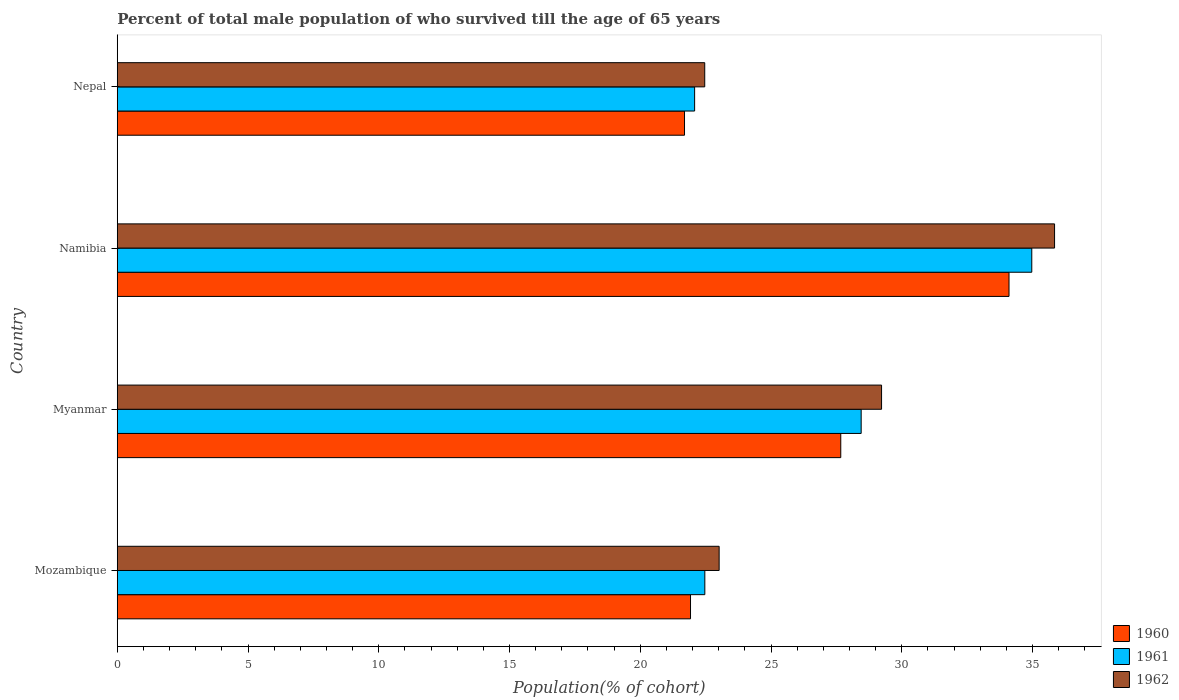How many groups of bars are there?
Give a very brief answer. 4. Are the number of bars per tick equal to the number of legend labels?
Offer a very short reply. Yes. Are the number of bars on each tick of the Y-axis equal?
Offer a very short reply. Yes. How many bars are there on the 4th tick from the top?
Keep it short and to the point. 3. What is the label of the 3rd group of bars from the top?
Ensure brevity in your answer.  Myanmar. What is the percentage of total male population who survived till the age of 65 years in 1962 in Myanmar?
Your answer should be very brief. 29.23. Across all countries, what is the maximum percentage of total male population who survived till the age of 65 years in 1962?
Your response must be concise. 35.84. Across all countries, what is the minimum percentage of total male population who survived till the age of 65 years in 1961?
Your answer should be compact. 22.08. In which country was the percentage of total male population who survived till the age of 65 years in 1960 maximum?
Make the answer very short. Namibia. In which country was the percentage of total male population who survived till the age of 65 years in 1962 minimum?
Ensure brevity in your answer.  Nepal. What is the total percentage of total male population who survived till the age of 65 years in 1961 in the graph?
Keep it short and to the point. 107.96. What is the difference between the percentage of total male population who survived till the age of 65 years in 1962 in Namibia and that in Nepal?
Your answer should be compact. 13.38. What is the difference between the percentage of total male population who survived till the age of 65 years in 1961 in Myanmar and the percentage of total male population who survived till the age of 65 years in 1962 in Nepal?
Keep it short and to the point. 5.98. What is the average percentage of total male population who survived till the age of 65 years in 1961 per country?
Offer a very short reply. 26.99. What is the difference between the percentage of total male population who survived till the age of 65 years in 1960 and percentage of total male population who survived till the age of 65 years in 1961 in Nepal?
Offer a very short reply. -0.39. What is the ratio of the percentage of total male population who survived till the age of 65 years in 1960 in Myanmar to that in Nepal?
Offer a terse response. 1.28. Is the percentage of total male population who survived till the age of 65 years in 1960 in Mozambique less than that in Namibia?
Make the answer very short. Yes. What is the difference between the highest and the second highest percentage of total male population who survived till the age of 65 years in 1960?
Your answer should be very brief. 6.43. What is the difference between the highest and the lowest percentage of total male population who survived till the age of 65 years in 1960?
Your answer should be very brief. 12.41. In how many countries, is the percentage of total male population who survived till the age of 65 years in 1961 greater than the average percentage of total male population who survived till the age of 65 years in 1961 taken over all countries?
Make the answer very short. 2. Is the sum of the percentage of total male population who survived till the age of 65 years in 1962 in Myanmar and Namibia greater than the maximum percentage of total male population who survived till the age of 65 years in 1960 across all countries?
Your response must be concise. Yes. Is it the case that in every country, the sum of the percentage of total male population who survived till the age of 65 years in 1962 and percentage of total male population who survived till the age of 65 years in 1961 is greater than the percentage of total male population who survived till the age of 65 years in 1960?
Your answer should be compact. Yes. How many bars are there?
Keep it short and to the point. 12. What is the difference between two consecutive major ticks on the X-axis?
Your answer should be compact. 5. Are the values on the major ticks of X-axis written in scientific E-notation?
Ensure brevity in your answer.  No. Does the graph contain grids?
Keep it short and to the point. No. How are the legend labels stacked?
Your response must be concise. Vertical. What is the title of the graph?
Make the answer very short. Percent of total male population of who survived till the age of 65 years. Does "2011" appear as one of the legend labels in the graph?
Your answer should be compact. No. What is the label or title of the X-axis?
Keep it short and to the point. Population(% of cohort). What is the Population(% of cohort) of 1960 in Mozambique?
Offer a terse response. 21.92. What is the Population(% of cohort) in 1961 in Mozambique?
Your answer should be compact. 22.47. What is the Population(% of cohort) of 1962 in Mozambique?
Ensure brevity in your answer.  23.02. What is the Population(% of cohort) in 1960 in Myanmar?
Provide a short and direct response. 27.67. What is the Population(% of cohort) of 1961 in Myanmar?
Make the answer very short. 28.45. What is the Population(% of cohort) of 1962 in Myanmar?
Your response must be concise. 29.23. What is the Population(% of cohort) of 1960 in Namibia?
Your answer should be compact. 34.1. What is the Population(% of cohort) of 1961 in Namibia?
Your response must be concise. 34.97. What is the Population(% of cohort) of 1962 in Namibia?
Your answer should be very brief. 35.84. What is the Population(% of cohort) in 1960 in Nepal?
Offer a very short reply. 21.69. What is the Population(% of cohort) of 1961 in Nepal?
Offer a terse response. 22.08. What is the Population(% of cohort) in 1962 in Nepal?
Your response must be concise. 22.46. Across all countries, what is the maximum Population(% of cohort) in 1960?
Keep it short and to the point. 34.1. Across all countries, what is the maximum Population(% of cohort) in 1961?
Make the answer very short. 34.97. Across all countries, what is the maximum Population(% of cohort) in 1962?
Your response must be concise. 35.84. Across all countries, what is the minimum Population(% of cohort) in 1960?
Give a very brief answer. 21.69. Across all countries, what is the minimum Population(% of cohort) in 1961?
Your response must be concise. 22.08. Across all countries, what is the minimum Population(% of cohort) of 1962?
Ensure brevity in your answer.  22.46. What is the total Population(% of cohort) of 1960 in the graph?
Your answer should be compact. 105.38. What is the total Population(% of cohort) in 1961 in the graph?
Make the answer very short. 107.96. What is the total Population(% of cohort) in 1962 in the graph?
Your response must be concise. 110.55. What is the difference between the Population(% of cohort) of 1960 in Mozambique and that in Myanmar?
Give a very brief answer. -5.75. What is the difference between the Population(% of cohort) of 1961 in Mozambique and that in Myanmar?
Make the answer very short. -5.98. What is the difference between the Population(% of cohort) of 1962 in Mozambique and that in Myanmar?
Offer a terse response. -6.21. What is the difference between the Population(% of cohort) in 1960 in Mozambique and that in Namibia?
Your answer should be very brief. -12.18. What is the difference between the Population(% of cohort) in 1961 in Mozambique and that in Namibia?
Your answer should be very brief. -12.5. What is the difference between the Population(% of cohort) of 1962 in Mozambique and that in Namibia?
Offer a very short reply. -12.83. What is the difference between the Population(% of cohort) of 1960 in Mozambique and that in Nepal?
Keep it short and to the point. 0.23. What is the difference between the Population(% of cohort) in 1961 in Mozambique and that in Nepal?
Ensure brevity in your answer.  0.39. What is the difference between the Population(% of cohort) of 1962 in Mozambique and that in Nepal?
Keep it short and to the point. 0.55. What is the difference between the Population(% of cohort) in 1960 in Myanmar and that in Namibia?
Your answer should be compact. -6.43. What is the difference between the Population(% of cohort) in 1961 in Myanmar and that in Namibia?
Make the answer very short. -6.52. What is the difference between the Population(% of cohort) of 1962 in Myanmar and that in Namibia?
Provide a short and direct response. -6.62. What is the difference between the Population(% of cohort) in 1960 in Myanmar and that in Nepal?
Provide a succinct answer. 5.98. What is the difference between the Population(% of cohort) of 1961 in Myanmar and that in Nepal?
Offer a very short reply. 6.37. What is the difference between the Population(% of cohort) of 1962 in Myanmar and that in Nepal?
Your answer should be very brief. 6.76. What is the difference between the Population(% of cohort) in 1960 in Namibia and that in Nepal?
Make the answer very short. 12.41. What is the difference between the Population(% of cohort) in 1961 in Namibia and that in Nepal?
Offer a terse response. 12.89. What is the difference between the Population(% of cohort) in 1962 in Namibia and that in Nepal?
Your answer should be very brief. 13.38. What is the difference between the Population(% of cohort) in 1960 in Mozambique and the Population(% of cohort) in 1961 in Myanmar?
Ensure brevity in your answer.  -6.53. What is the difference between the Population(% of cohort) of 1960 in Mozambique and the Population(% of cohort) of 1962 in Myanmar?
Keep it short and to the point. -7.31. What is the difference between the Population(% of cohort) in 1961 in Mozambique and the Population(% of cohort) in 1962 in Myanmar?
Your answer should be compact. -6.76. What is the difference between the Population(% of cohort) of 1960 in Mozambique and the Population(% of cohort) of 1961 in Namibia?
Ensure brevity in your answer.  -13.05. What is the difference between the Population(% of cohort) of 1960 in Mozambique and the Population(% of cohort) of 1962 in Namibia?
Offer a terse response. -13.92. What is the difference between the Population(% of cohort) in 1961 in Mozambique and the Population(% of cohort) in 1962 in Namibia?
Provide a short and direct response. -13.37. What is the difference between the Population(% of cohort) of 1960 in Mozambique and the Population(% of cohort) of 1961 in Nepal?
Provide a short and direct response. -0.16. What is the difference between the Population(% of cohort) in 1960 in Mozambique and the Population(% of cohort) in 1962 in Nepal?
Give a very brief answer. -0.54. What is the difference between the Population(% of cohort) of 1961 in Mozambique and the Population(% of cohort) of 1962 in Nepal?
Provide a succinct answer. 0. What is the difference between the Population(% of cohort) of 1960 in Myanmar and the Population(% of cohort) of 1961 in Namibia?
Your response must be concise. -7.3. What is the difference between the Population(% of cohort) in 1960 in Myanmar and the Population(% of cohort) in 1962 in Namibia?
Make the answer very short. -8.18. What is the difference between the Population(% of cohort) of 1961 in Myanmar and the Population(% of cohort) of 1962 in Namibia?
Keep it short and to the point. -7.4. What is the difference between the Population(% of cohort) in 1960 in Myanmar and the Population(% of cohort) in 1961 in Nepal?
Ensure brevity in your answer.  5.59. What is the difference between the Population(% of cohort) of 1960 in Myanmar and the Population(% of cohort) of 1962 in Nepal?
Make the answer very short. 5.2. What is the difference between the Population(% of cohort) of 1961 in Myanmar and the Population(% of cohort) of 1962 in Nepal?
Ensure brevity in your answer.  5.98. What is the difference between the Population(% of cohort) of 1960 in Namibia and the Population(% of cohort) of 1961 in Nepal?
Your response must be concise. 12.02. What is the difference between the Population(% of cohort) of 1960 in Namibia and the Population(% of cohort) of 1962 in Nepal?
Offer a very short reply. 11.64. What is the difference between the Population(% of cohort) in 1961 in Namibia and the Population(% of cohort) in 1962 in Nepal?
Offer a very short reply. 12.51. What is the average Population(% of cohort) in 1960 per country?
Offer a terse response. 26.34. What is the average Population(% of cohort) in 1961 per country?
Your answer should be compact. 26.99. What is the average Population(% of cohort) in 1962 per country?
Your answer should be very brief. 27.64. What is the difference between the Population(% of cohort) of 1960 and Population(% of cohort) of 1961 in Mozambique?
Keep it short and to the point. -0.55. What is the difference between the Population(% of cohort) of 1960 and Population(% of cohort) of 1962 in Mozambique?
Make the answer very short. -1.09. What is the difference between the Population(% of cohort) of 1961 and Population(% of cohort) of 1962 in Mozambique?
Your response must be concise. -0.55. What is the difference between the Population(% of cohort) of 1960 and Population(% of cohort) of 1961 in Myanmar?
Make the answer very short. -0.78. What is the difference between the Population(% of cohort) of 1960 and Population(% of cohort) of 1962 in Myanmar?
Make the answer very short. -1.56. What is the difference between the Population(% of cohort) in 1961 and Population(% of cohort) in 1962 in Myanmar?
Your answer should be compact. -0.78. What is the difference between the Population(% of cohort) in 1960 and Population(% of cohort) in 1961 in Namibia?
Keep it short and to the point. -0.87. What is the difference between the Population(% of cohort) of 1960 and Population(% of cohort) of 1962 in Namibia?
Ensure brevity in your answer.  -1.74. What is the difference between the Population(% of cohort) of 1961 and Population(% of cohort) of 1962 in Namibia?
Your answer should be compact. -0.87. What is the difference between the Population(% of cohort) in 1960 and Population(% of cohort) in 1961 in Nepal?
Provide a succinct answer. -0.39. What is the difference between the Population(% of cohort) in 1960 and Population(% of cohort) in 1962 in Nepal?
Make the answer very short. -0.77. What is the difference between the Population(% of cohort) in 1961 and Population(% of cohort) in 1962 in Nepal?
Offer a terse response. -0.39. What is the ratio of the Population(% of cohort) of 1960 in Mozambique to that in Myanmar?
Provide a short and direct response. 0.79. What is the ratio of the Population(% of cohort) of 1961 in Mozambique to that in Myanmar?
Keep it short and to the point. 0.79. What is the ratio of the Population(% of cohort) in 1962 in Mozambique to that in Myanmar?
Your answer should be very brief. 0.79. What is the ratio of the Population(% of cohort) in 1960 in Mozambique to that in Namibia?
Provide a short and direct response. 0.64. What is the ratio of the Population(% of cohort) of 1961 in Mozambique to that in Namibia?
Keep it short and to the point. 0.64. What is the ratio of the Population(% of cohort) in 1962 in Mozambique to that in Namibia?
Keep it short and to the point. 0.64. What is the ratio of the Population(% of cohort) in 1960 in Mozambique to that in Nepal?
Give a very brief answer. 1.01. What is the ratio of the Population(% of cohort) in 1961 in Mozambique to that in Nepal?
Your response must be concise. 1.02. What is the ratio of the Population(% of cohort) in 1962 in Mozambique to that in Nepal?
Ensure brevity in your answer.  1.02. What is the ratio of the Population(% of cohort) in 1960 in Myanmar to that in Namibia?
Offer a terse response. 0.81. What is the ratio of the Population(% of cohort) of 1961 in Myanmar to that in Namibia?
Your answer should be very brief. 0.81. What is the ratio of the Population(% of cohort) of 1962 in Myanmar to that in Namibia?
Ensure brevity in your answer.  0.82. What is the ratio of the Population(% of cohort) in 1960 in Myanmar to that in Nepal?
Your answer should be compact. 1.28. What is the ratio of the Population(% of cohort) of 1961 in Myanmar to that in Nepal?
Your answer should be very brief. 1.29. What is the ratio of the Population(% of cohort) of 1962 in Myanmar to that in Nepal?
Provide a short and direct response. 1.3. What is the ratio of the Population(% of cohort) of 1960 in Namibia to that in Nepal?
Provide a succinct answer. 1.57. What is the ratio of the Population(% of cohort) of 1961 in Namibia to that in Nepal?
Give a very brief answer. 1.58. What is the ratio of the Population(% of cohort) in 1962 in Namibia to that in Nepal?
Give a very brief answer. 1.6. What is the difference between the highest and the second highest Population(% of cohort) of 1960?
Your answer should be very brief. 6.43. What is the difference between the highest and the second highest Population(% of cohort) of 1961?
Your answer should be very brief. 6.52. What is the difference between the highest and the second highest Population(% of cohort) in 1962?
Your answer should be compact. 6.62. What is the difference between the highest and the lowest Population(% of cohort) of 1960?
Provide a succinct answer. 12.41. What is the difference between the highest and the lowest Population(% of cohort) of 1961?
Your answer should be very brief. 12.89. What is the difference between the highest and the lowest Population(% of cohort) in 1962?
Ensure brevity in your answer.  13.38. 